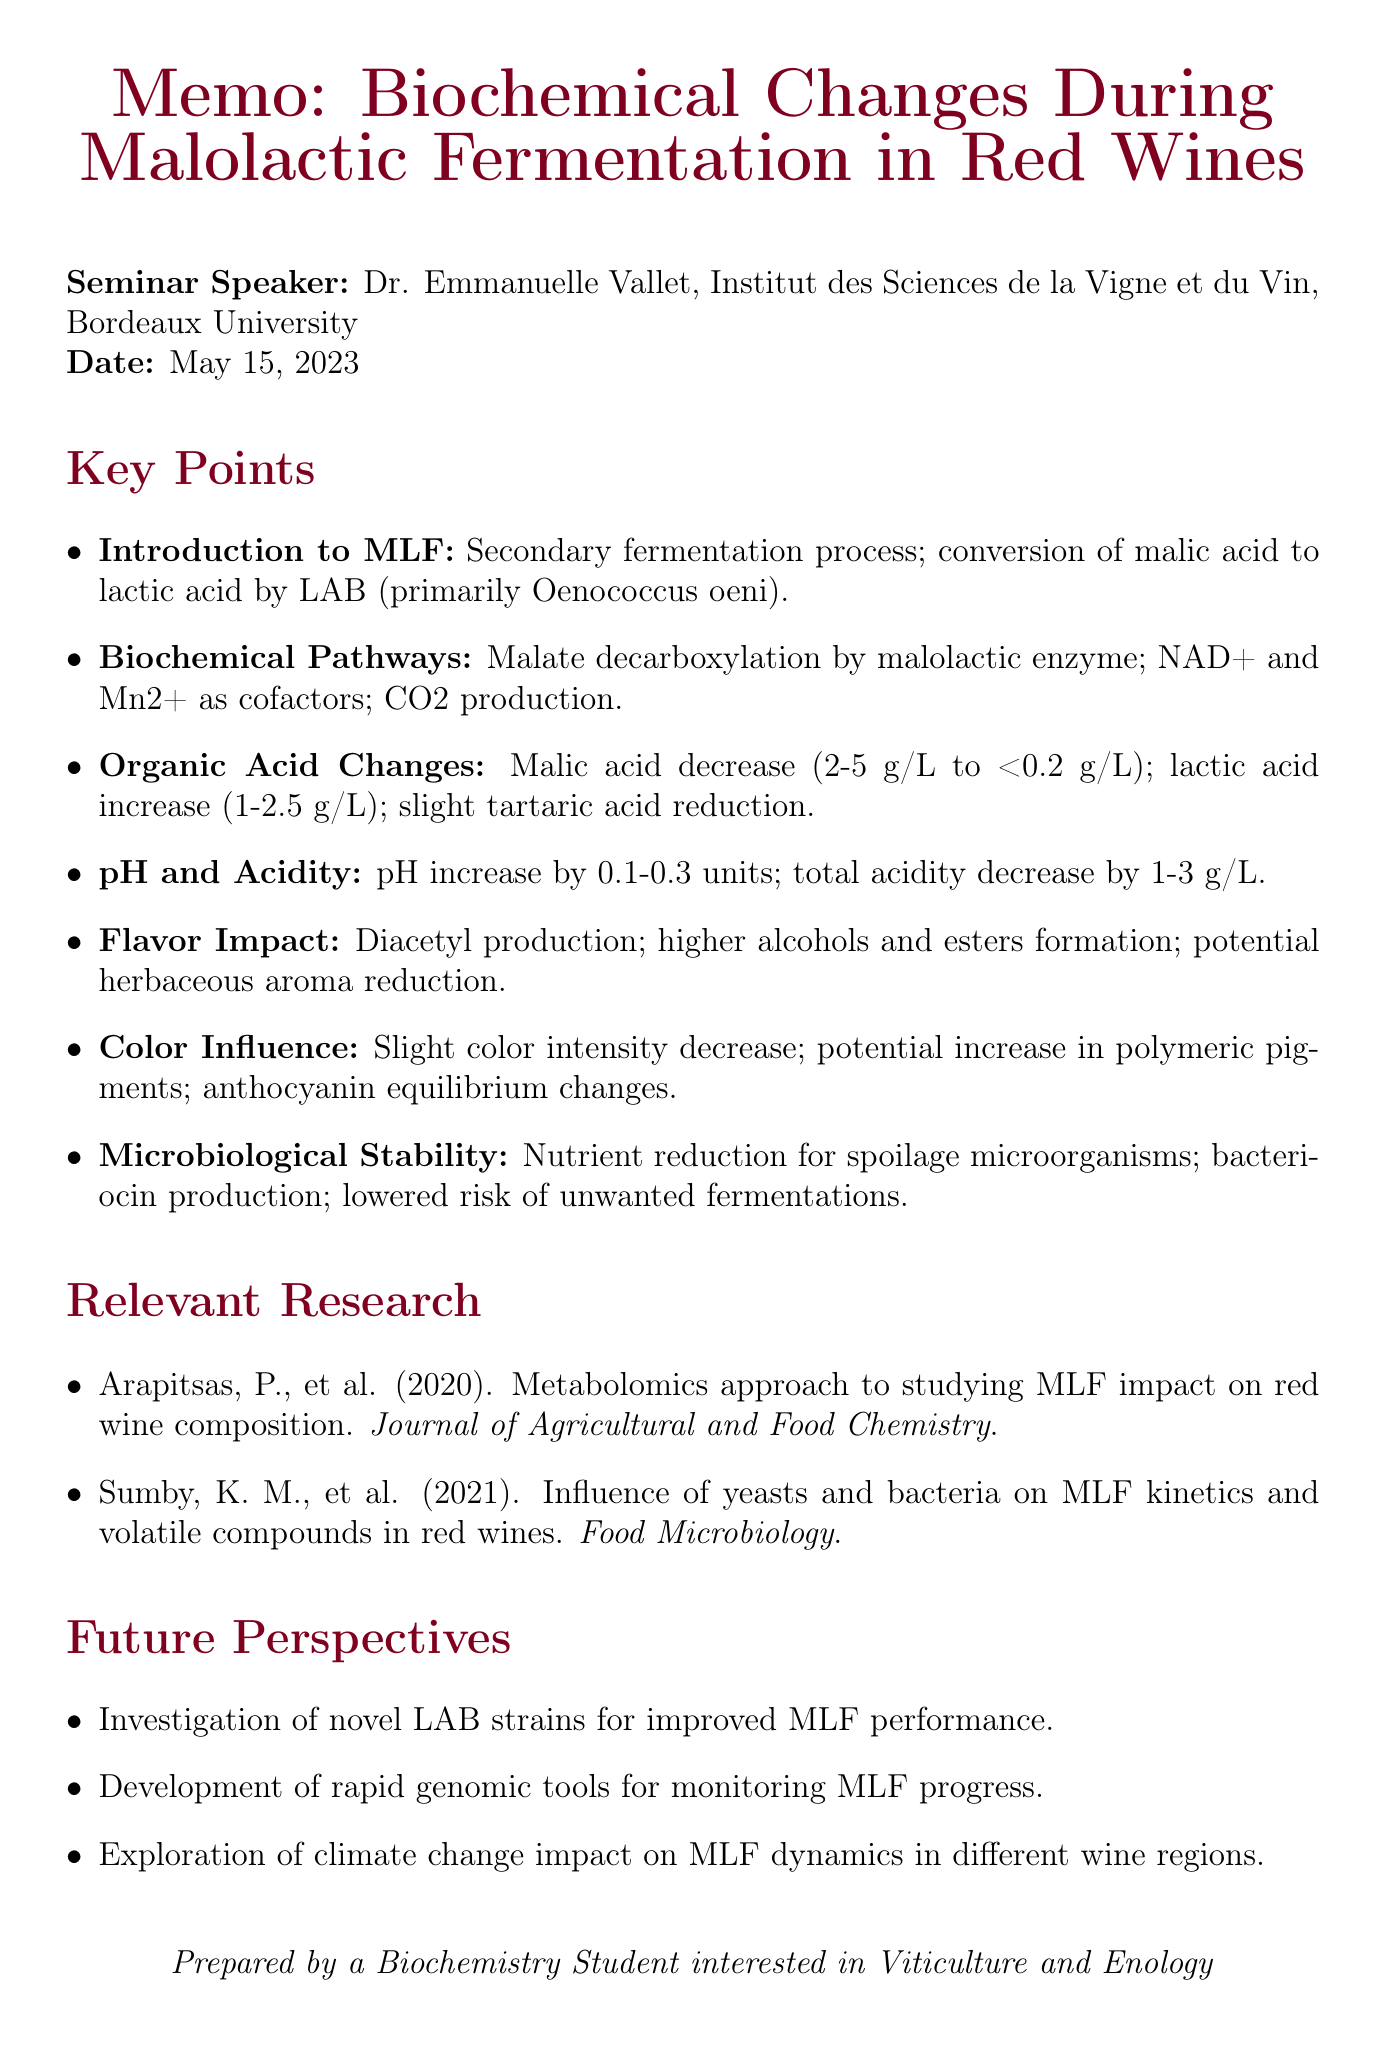What is the title of the seminar? The title of the seminar is explicitly mentioned at the beginning of the memo.
Answer: Biochemical Changes During Malolactic Fermentation in Red Wines Who is the speaker? The memo lists the speaker's name right after the seminar title.
Answer: Dr. Emmanuelle Vallet What university is the speaker affiliated with? The speaker's affiliation is noted directly following their name in the memo.
Answer: Bordeaux University What is the date of the seminar? The seminar date is specified in the memo under the speaker's information.
Answer: May 15, 2023 Which bacterial species is primarily responsible for malolactic fermentation? The memo identifies the primary species involved in MLF under the 'Introduction to MLF' section.
Answer: Oenococcus oeni How much does malic acid typically decrease during MLF? This specific information is given in the 'Changes in Organic Acid Composition' section.
Answer: from 2-5 g/L to <0.2 g/L What impact does MLF have on total acidity? The impact on total acidity is detailed in the 'pH and Total Acidity Alterations' section.
Answer: Decrease by 1-3 g/L What is one of the future perspectives mentioned in the seminar? The memo lists future perspectives regarding MLF directly at the end.
Answer: Investigation of novel LAB strains for improved MLF performance What type of aroma is produced from citric acid metabolism during MLF? This information is found in the 'Impact on Wine Flavor Compounds' section of the memo.
Answer: Diacetyl (buttery aroma) 